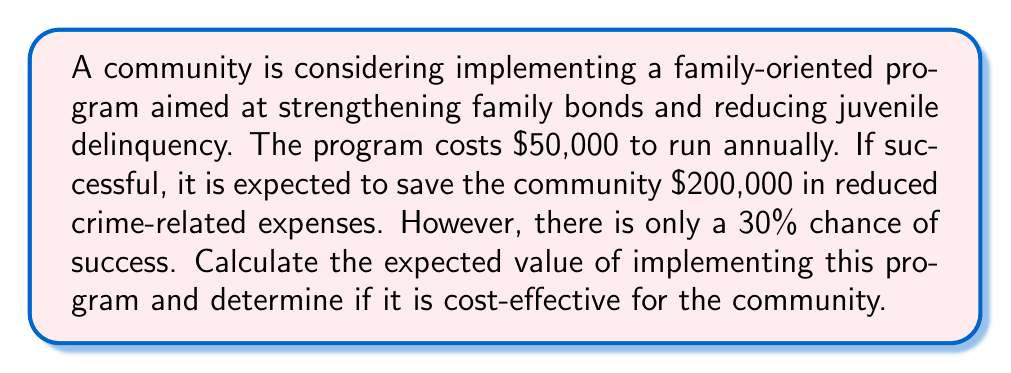Can you solve this math problem? To determine if the program is cost-effective, we need to calculate its expected value. The expected value is the sum of each possible outcome multiplied by its probability.

Step 1: Identify the possible outcomes and their probabilities
- Success: 30% chance (0.3 probability)
- Failure: 70% chance (0.7 probability)

Step 2: Calculate the net value for each outcome
- Success: Savings - Cost = $200,000 - $50,000 = $150,000
- Failure: -Cost = -$50,000

Step 3: Calculate the expected value
Expected Value = (Probability of Success × Net Value of Success) + (Probability of Failure × Net Value of Failure)

$$EV = (0.3 \times 150,000) + (0.7 \times (-50,000))$$
$$EV = 45,000 - 35,000$$
$$EV = 10,000$$

Step 4: Interpret the result
The expected value is positive ($10,000), which means that, on average, the community can expect to gain $10,000 by implementing this program.

Step 5: Determine cost-effectiveness
Since the expected value is positive, the program is considered cost-effective. The community can expect to save more money than it spends on the program in the long run.
Answer: $10,000; cost-effective 